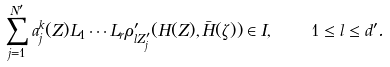Convert formula to latex. <formula><loc_0><loc_0><loc_500><loc_500>\sum _ { j = 1 } ^ { N ^ { \prime } } a _ { j } ^ { k } ( Z ) L _ { 1 } \cdots L _ { r } \rho _ { l Z _ { j } ^ { \prime } } ^ { \prime } ( H ( Z ) , \bar { H } ( \zeta ) ) \in I , \quad 1 \leq l \leq d ^ { \prime } .</formula> 